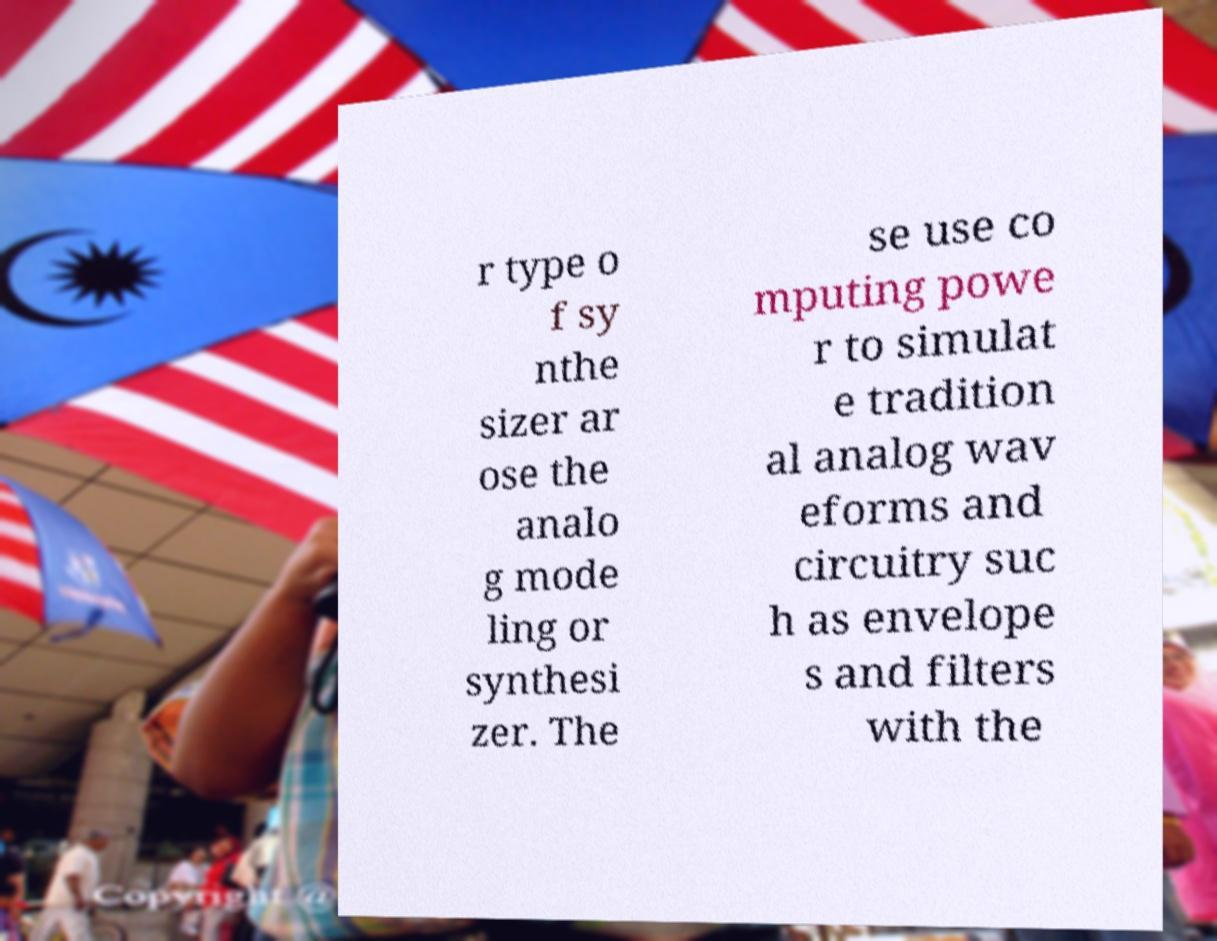I need the written content from this picture converted into text. Can you do that? r type o f sy nthe sizer ar ose the analo g mode ling or synthesi zer. The se use co mputing powe r to simulat e tradition al analog wav eforms and circuitry suc h as envelope s and filters with the 